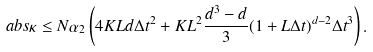Convert formula to latex. <formula><loc_0><loc_0><loc_500><loc_500>\ a b s \kappa \leq N \alpha _ { 2 } \left ( 4 K L d \Delta t ^ { 2 } + K L ^ { 2 } \frac { d ^ { 3 } - d } { 3 } ( 1 + L \Delta t ) ^ { d - 2 } \Delta t ^ { 3 } \right ) .</formula> 